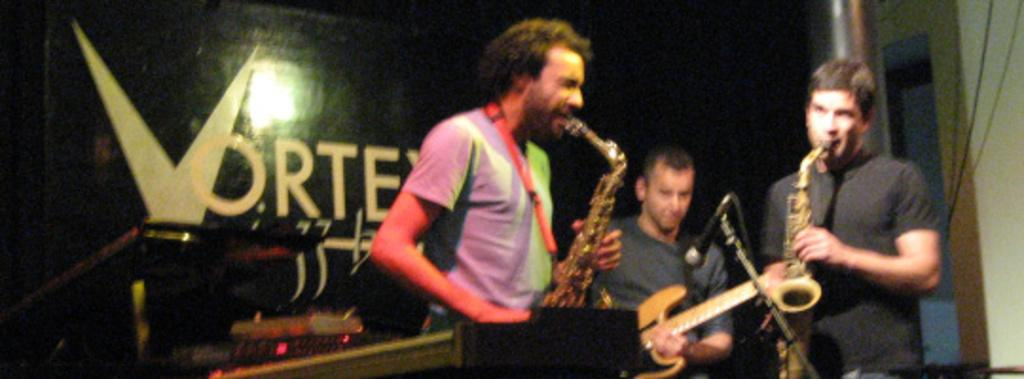How many people are in the image? There are three people in the image. What are the people doing in the image? The people are playing musical instruments. What color t-shirts are two of the people wearing? Two of the people are wearing black t-shirts. What type of cheese is being used to play the musical instruments in the image? There is no cheese present in the image, and the musical instruments are not being played with cheese. 